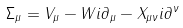<formula> <loc_0><loc_0><loc_500><loc_500>\Sigma _ { \mu } = V _ { \mu } - W i \partial _ { \mu } - X _ { \mu \nu } i \partial ^ { \nu }</formula> 